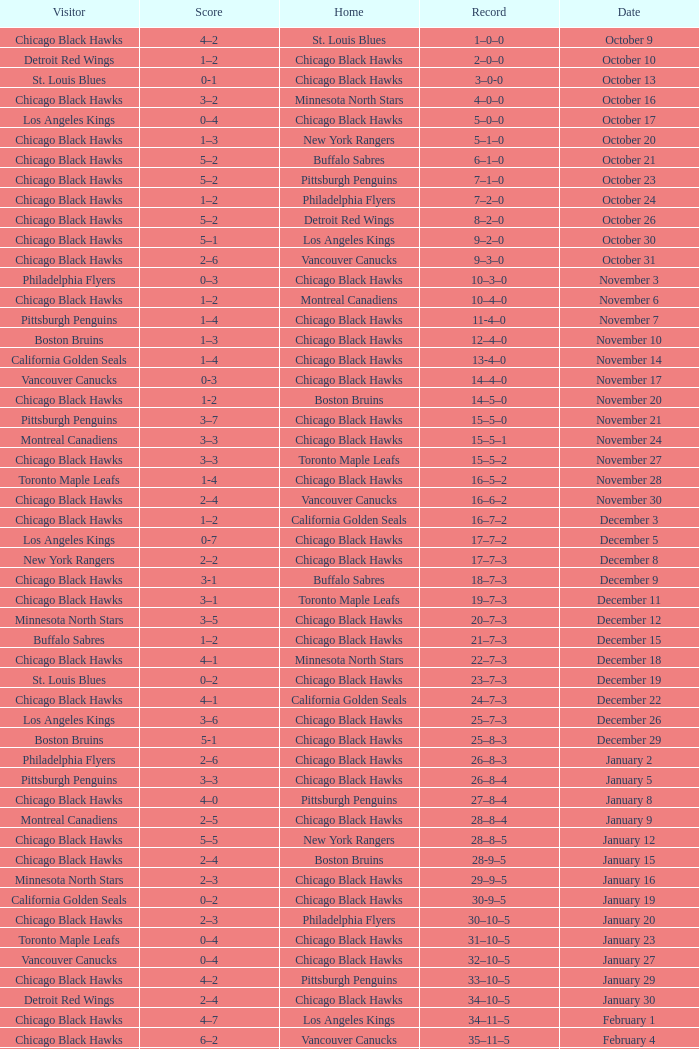What is the Record of the February 26 date? 39–16–7. 